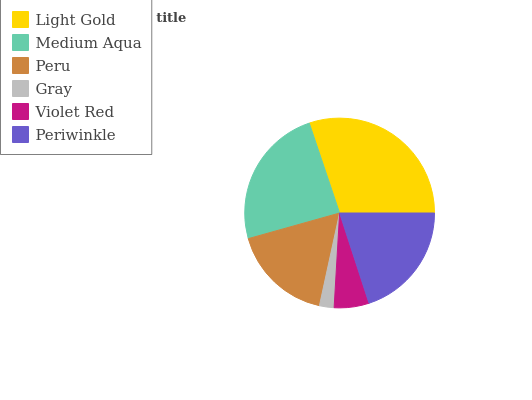Is Gray the minimum?
Answer yes or no. Yes. Is Light Gold the maximum?
Answer yes or no. Yes. Is Medium Aqua the minimum?
Answer yes or no. No. Is Medium Aqua the maximum?
Answer yes or no. No. Is Light Gold greater than Medium Aqua?
Answer yes or no. Yes. Is Medium Aqua less than Light Gold?
Answer yes or no. Yes. Is Medium Aqua greater than Light Gold?
Answer yes or no. No. Is Light Gold less than Medium Aqua?
Answer yes or no. No. Is Periwinkle the high median?
Answer yes or no. Yes. Is Peru the low median?
Answer yes or no. Yes. Is Gray the high median?
Answer yes or no. No. Is Violet Red the low median?
Answer yes or no. No. 